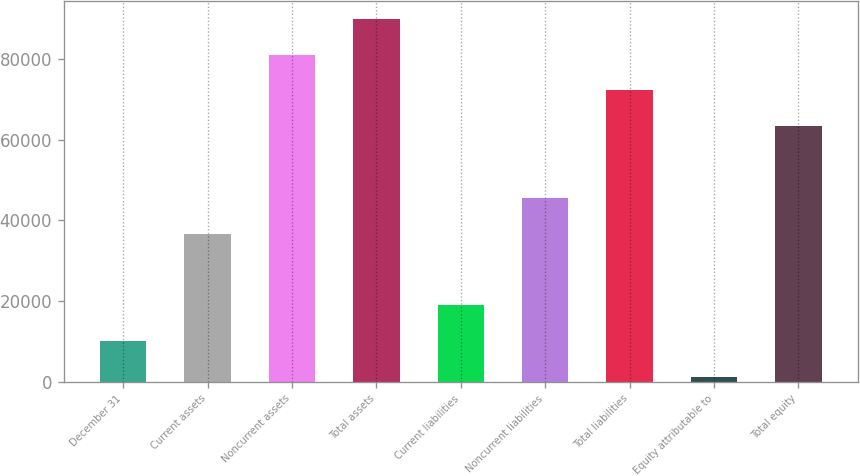Convert chart to OTSL. <chart><loc_0><loc_0><loc_500><loc_500><bar_chart><fcel>December 31<fcel>Current assets<fcel>Noncurrent assets<fcel>Total assets<fcel>Current liabilities<fcel>Noncurrent liabilities<fcel>Total liabilities<fcel>Equity attributable to<fcel>Total equity<nl><fcel>10059<fcel>36696<fcel>81091<fcel>89970<fcel>18938<fcel>45575<fcel>72212<fcel>1180<fcel>63333<nl></chart> 